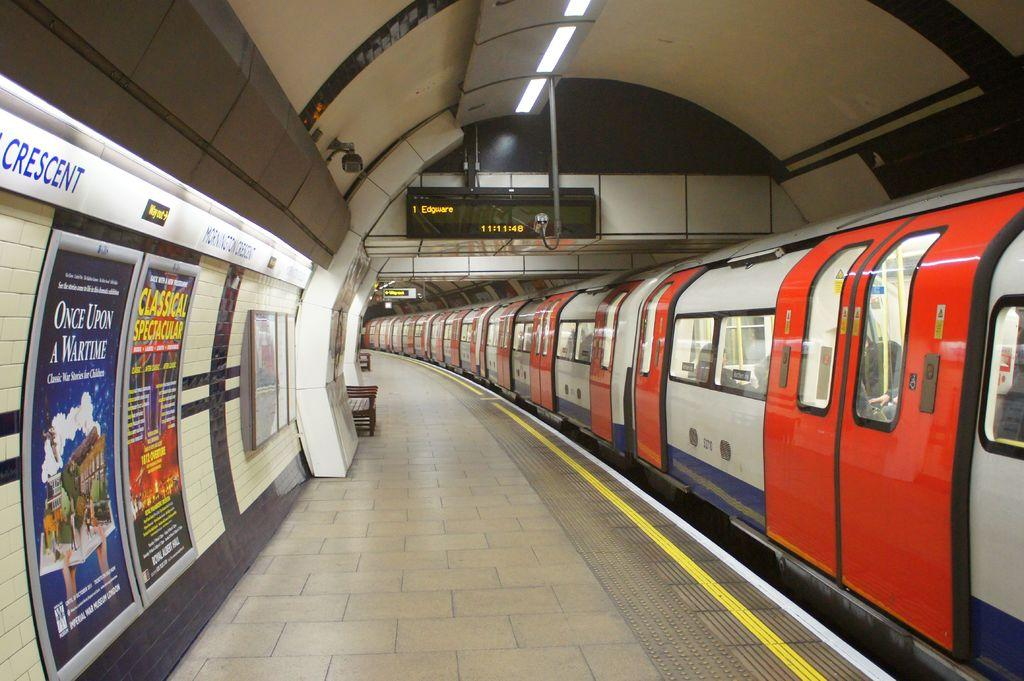<image>
Share a concise interpretation of the image provided. a subway train in a tunnel near a sign reading Edgware 